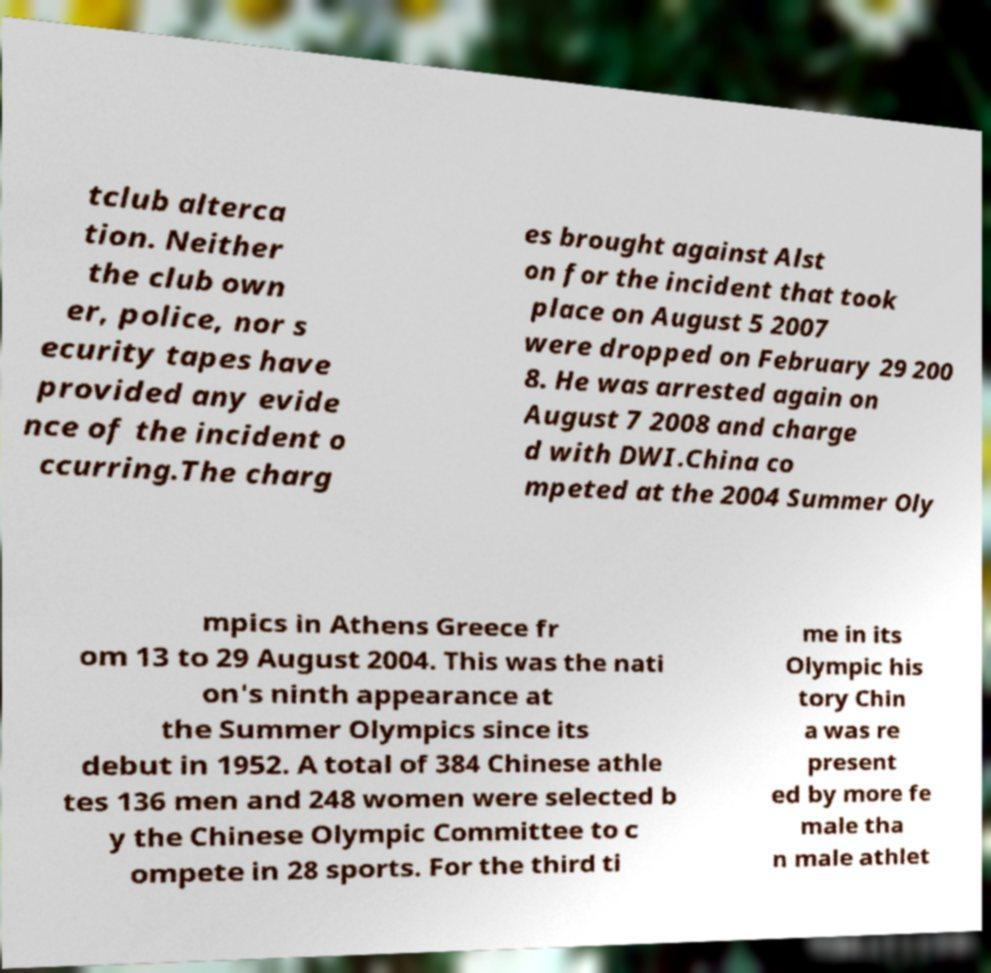For documentation purposes, I need the text within this image transcribed. Could you provide that? tclub alterca tion. Neither the club own er, police, nor s ecurity tapes have provided any evide nce of the incident o ccurring.The charg es brought against Alst on for the incident that took place on August 5 2007 were dropped on February 29 200 8. He was arrested again on August 7 2008 and charge d with DWI.China co mpeted at the 2004 Summer Oly mpics in Athens Greece fr om 13 to 29 August 2004. This was the nati on's ninth appearance at the Summer Olympics since its debut in 1952. A total of 384 Chinese athle tes 136 men and 248 women were selected b y the Chinese Olympic Committee to c ompete in 28 sports. For the third ti me in its Olympic his tory Chin a was re present ed by more fe male tha n male athlet 